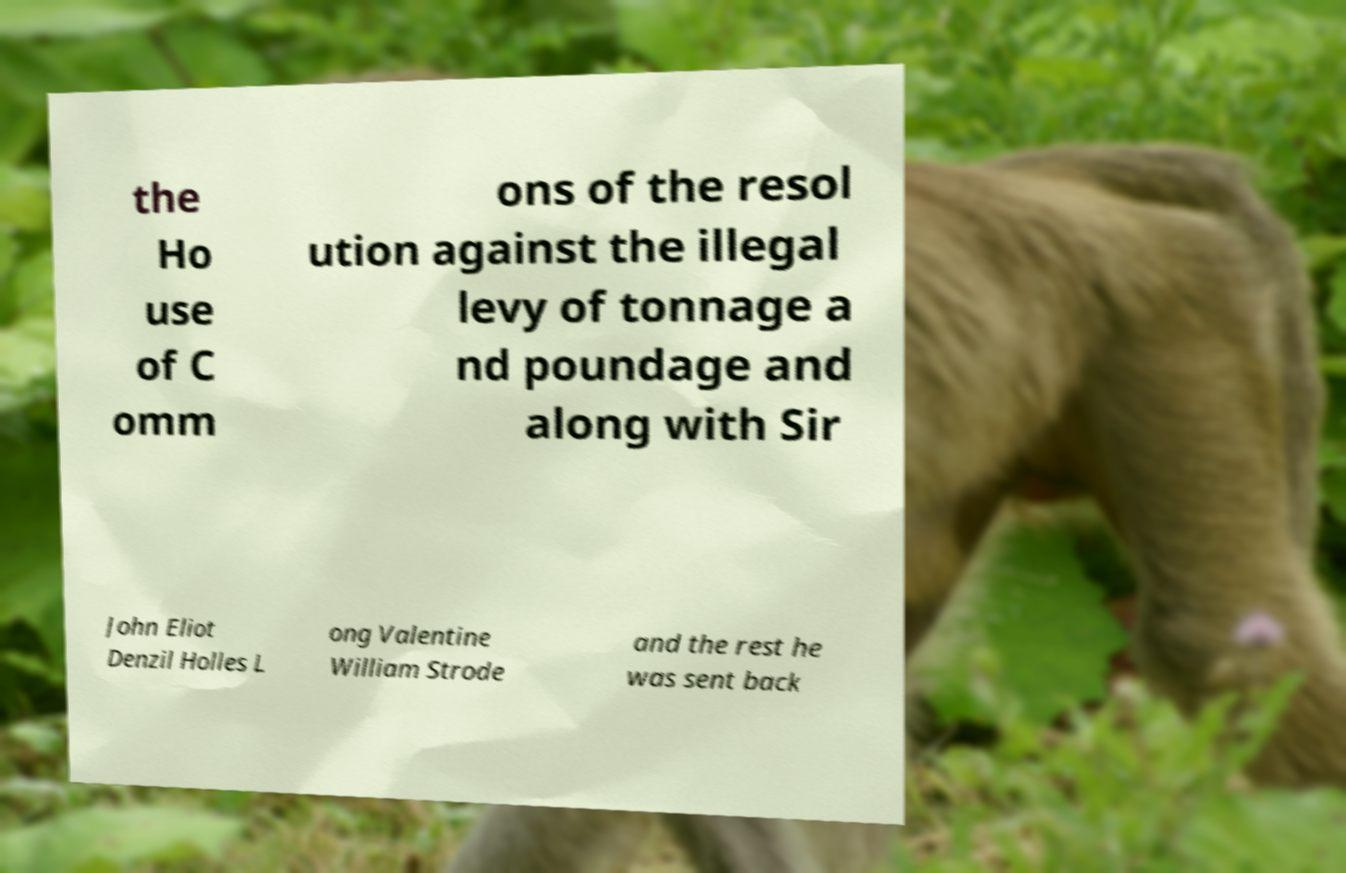For documentation purposes, I need the text within this image transcribed. Could you provide that? the Ho use of C omm ons of the resol ution against the illegal levy of tonnage a nd poundage and along with Sir John Eliot Denzil Holles L ong Valentine William Strode and the rest he was sent back 